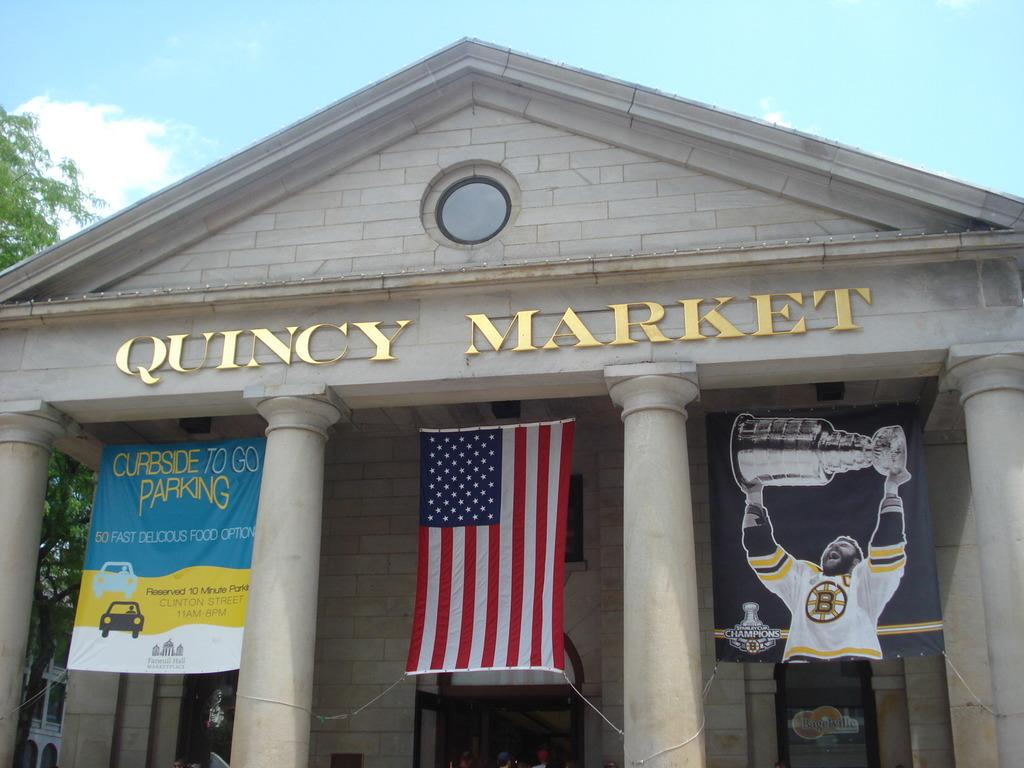<image>
Offer a succinct explanation of the picture presented. An American flag is hanging from a building that says Quincy Market in gold letters. 